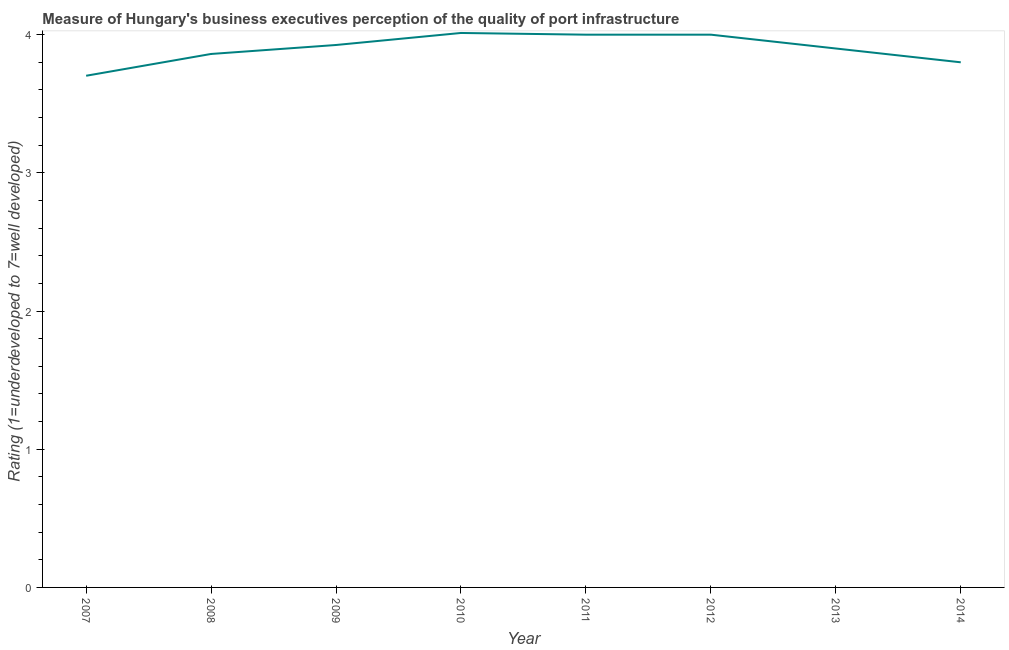What is the rating measuring quality of port infrastructure in 2008?
Give a very brief answer. 3.86. Across all years, what is the maximum rating measuring quality of port infrastructure?
Your answer should be very brief. 4.01. Across all years, what is the minimum rating measuring quality of port infrastructure?
Offer a very short reply. 3.7. In which year was the rating measuring quality of port infrastructure minimum?
Provide a short and direct response. 2007. What is the sum of the rating measuring quality of port infrastructure?
Your answer should be very brief. 31.2. What is the difference between the rating measuring quality of port infrastructure in 2013 and 2014?
Ensure brevity in your answer.  0.1. What is the average rating measuring quality of port infrastructure per year?
Your answer should be very brief. 3.9. What is the median rating measuring quality of port infrastructure?
Provide a short and direct response. 3.91. Do a majority of the years between 2011 and 2007 (inclusive) have rating measuring quality of port infrastructure greater than 0.2 ?
Keep it short and to the point. Yes. What is the ratio of the rating measuring quality of port infrastructure in 2012 to that in 2014?
Make the answer very short. 1.05. What is the difference between the highest and the second highest rating measuring quality of port infrastructure?
Ensure brevity in your answer.  0.01. What is the difference between the highest and the lowest rating measuring quality of port infrastructure?
Give a very brief answer. 0.31. In how many years, is the rating measuring quality of port infrastructure greater than the average rating measuring quality of port infrastructure taken over all years?
Provide a short and direct response. 4. How many years are there in the graph?
Ensure brevity in your answer.  8. Are the values on the major ticks of Y-axis written in scientific E-notation?
Provide a succinct answer. No. What is the title of the graph?
Your answer should be very brief. Measure of Hungary's business executives perception of the quality of port infrastructure. What is the label or title of the X-axis?
Offer a terse response. Year. What is the label or title of the Y-axis?
Make the answer very short. Rating (1=underdeveloped to 7=well developed) . What is the Rating (1=underdeveloped to 7=well developed)  in 2007?
Your answer should be compact. 3.7. What is the Rating (1=underdeveloped to 7=well developed)  of 2008?
Your response must be concise. 3.86. What is the Rating (1=underdeveloped to 7=well developed)  of 2009?
Provide a short and direct response. 3.93. What is the Rating (1=underdeveloped to 7=well developed)  in 2010?
Offer a very short reply. 4.01. What is the difference between the Rating (1=underdeveloped to 7=well developed)  in 2007 and 2008?
Give a very brief answer. -0.16. What is the difference between the Rating (1=underdeveloped to 7=well developed)  in 2007 and 2009?
Your response must be concise. -0.22. What is the difference between the Rating (1=underdeveloped to 7=well developed)  in 2007 and 2010?
Your response must be concise. -0.31. What is the difference between the Rating (1=underdeveloped to 7=well developed)  in 2007 and 2011?
Give a very brief answer. -0.3. What is the difference between the Rating (1=underdeveloped to 7=well developed)  in 2007 and 2012?
Provide a succinct answer. -0.3. What is the difference between the Rating (1=underdeveloped to 7=well developed)  in 2007 and 2013?
Offer a very short reply. -0.2. What is the difference between the Rating (1=underdeveloped to 7=well developed)  in 2007 and 2014?
Offer a terse response. -0.1. What is the difference between the Rating (1=underdeveloped to 7=well developed)  in 2008 and 2009?
Make the answer very short. -0.06. What is the difference between the Rating (1=underdeveloped to 7=well developed)  in 2008 and 2010?
Your answer should be very brief. -0.15. What is the difference between the Rating (1=underdeveloped to 7=well developed)  in 2008 and 2011?
Keep it short and to the point. -0.14. What is the difference between the Rating (1=underdeveloped to 7=well developed)  in 2008 and 2012?
Give a very brief answer. -0.14. What is the difference between the Rating (1=underdeveloped to 7=well developed)  in 2008 and 2013?
Offer a terse response. -0.04. What is the difference between the Rating (1=underdeveloped to 7=well developed)  in 2008 and 2014?
Your response must be concise. 0.06. What is the difference between the Rating (1=underdeveloped to 7=well developed)  in 2009 and 2010?
Ensure brevity in your answer.  -0.09. What is the difference between the Rating (1=underdeveloped to 7=well developed)  in 2009 and 2011?
Make the answer very short. -0.07. What is the difference between the Rating (1=underdeveloped to 7=well developed)  in 2009 and 2012?
Make the answer very short. -0.07. What is the difference between the Rating (1=underdeveloped to 7=well developed)  in 2009 and 2013?
Keep it short and to the point. 0.03. What is the difference between the Rating (1=underdeveloped to 7=well developed)  in 2009 and 2014?
Give a very brief answer. 0.13. What is the difference between the Rating (1=underdeveloped to 7=well developed)  in 2010 and 2011?
Make the answer very short. 0.01. What is the difference between the Rating (1=underdeveloped to 7=well developed)  in 2010 and 2012?
Provide a succinct answer. 0.01. What is the difference between the Rating (1=underdeveloped to 7=well developed)  in 2010 and 2013?
Your answer should be compact. 0.11. What is the difference between the Rating (1=underdeveloped to 7=well developed)  in 2010 and 2014?
Your answer should be very brief. 0.21. What is the difference between the Rating (1=underdeveloped to 7=well developed)  in 2011 and 2013?
Make the answer very short. 0.1. What is the difference between the Rating (1=underdeveloped to 7=well developed)  in 2011 and 2014?
Give a very brief answer. 0.2. What is the difference between the Rating (1=underdeveloped to 7=well developed)  in 2012 and 2013?
Make the answer very short. 0.1. What is the difference between the Rating (1=underdeveloped to 7=well developed)  in 2012 and 2014?
Your answer should be very brief. 0.2. What is the ratio of the Rating (1=underdeveloped to 7=well developed)  in 2007 to that in 2008?
Make the answer very short. 0.96. What is the ratio of the Rating (1=underdeveloped to 7=well developed)  in 2007 to that in 2009?
Offer a terse response. 0.94. What is the ratio of the Rating (1=underdeveloped to 7=well developed)  in 2007 to that in 2010?
Ensure brevity in your answer.  0.92. What is the ratio of the Rating (1=underdeveloped to 7=well developed)  in 2007 to that in 2011?
Offer a terse response. 0.93. What is the ratio of the Rating (1=underdeveloped to 7=well developed)  in 2007 to that in 2012?
Ensure brevity in your answer.  0.93. What is the ratio of the Rating (1=underdeveloped to 7=well developed)  in 2007 to that in 2013?
Make the answer very short. 0.95. What is the ratio of the Rating (1=underdeveloped to 7=well developed)  in 2007 to that in 2014?
Provide a short and direct response. 0.97. What is the ratio of the Rating (1=underdeveloped to 7=well developed)  in 2008 to that in 2009?
Your answer should be compact. 0.98. What is the ratio of the Rating (1=underdeveloped to 7=well developed)  in 2008 to that in 2012?
Make the answer very short. 0.96. What is the ratio of the Rating (1=underdeveloped to 7=well developed)  in 2008 to that in 2014?
Your answer should be compact. 1.02. What is the ratio of the Rating (1=underdeveloped to 7=well developed)  in 2009 to that in 2011?
Your answer should be compact. 0.98. What is the ratio of the Rating (1=underdeveloped to 7=well developed)  in 2009 to that in 2012?
Provide a succinct answer. 0.98. What is the ratio of the Rating (1=underdeveloped to 7=well developed)  in 2009 to that in 2013?
Offer a very short reply. 1.01. What is the ratio of the Rating (1=underdeveloped to 7=well developed)  in 2009 to that in 2014?
Provide a short and direct response. 1.03. What is the ratio of the Rating (1=underdeveloped to 7=well developed)  in 2010 to that in 2012?
Provide a succinct answer. 1. What is the ratio of the Rating (1=underdeveloped to 7=well developed)  in 2010 to that in 2013?
Your answer should be compact. 1.03. What is the ratio of the Rating (1=underdeveloped to 7=well developed)  in 2010 to that in 2014?
Provide a succinct answer. 1.06. What is the ratio of the Rating (1=underdeveloped to 7=well developed)  in 2011 to that in 2012?
Ensure brevity in your answer.  1. What is the ratio of the Rating (1=underdeveloped to 7=well developed)  in 2011 to that in 2014?
Your answer should be very brief. 1.05. What is the ratio of the Rating (1=underdeveloped to 7=well developed)  in 2012 to that in 2014?
Offer a terse response. 1.05. 